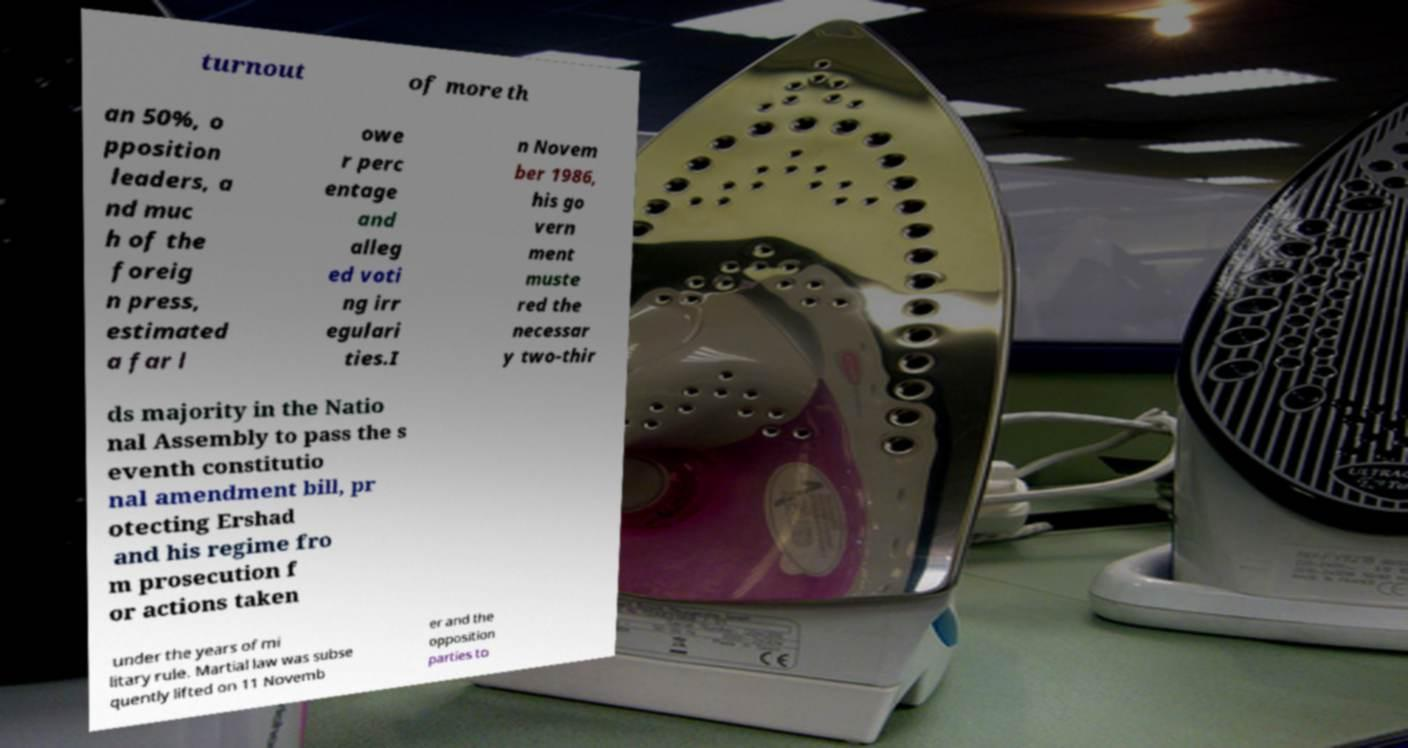Please read and relay the text visible in this image. What does it say? turnout of more th an 50%, o pposition leaders, a nd muc h of the foreig n press, estimated a far l owe r perc entage and alleg ed voti ng irr egulari ties.I n Novem ber 1986, his go vern ment muste red the necessar y two-thir ds majority in the Natio nal Assembly to pass the s eventh constitutio nal amendment bill, pr otecting Ershad and his regime fro m prosecution f or actions taken under the years of mi litary rule. Martial law was subse quently lifted on 11 Novemb er and the opposition parties to 